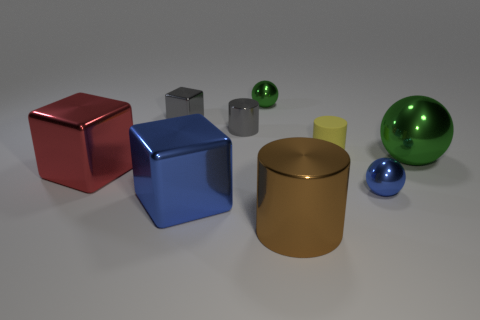Is the size of the gray thing that is on the right side of the blue metallic block the same as the large brown cylinder?
Give a very brief answer. No. How many things are tiny green shiny balls or large brown metallic cylinders?
Ensure brevity in your answer.  2. What is the thing that is in front of the blue shiny thing that is in front of the blue shiny object right of the big blue thing made of?
Provide a succinct answer. Metal. What is the material of the large thing that is left of the gray metallic cube?
Your response must be concise. Metal. Is there a metal ball that has the same size as the red cube?
Ensure brevity in your answer.  Yes. Does the big metallic object that is to the right of the brown cylinder have the same color as the rubber object?
Your response must be concise. No. How many yellow objects are large metallic blocks or objects?
Provide a succinct answer. 1. How many other big cylinders have the same color as the big cylinder?
Your answer should be very brief. 0. Is the material of the large blue block the same as the tiny yellow thing?
Your answer should be very brief. No. How many big red shiny blocks are to the left of the blue metallic thing that is on the left side of the small blue sphere?
Provide a short and direct response. 1. 